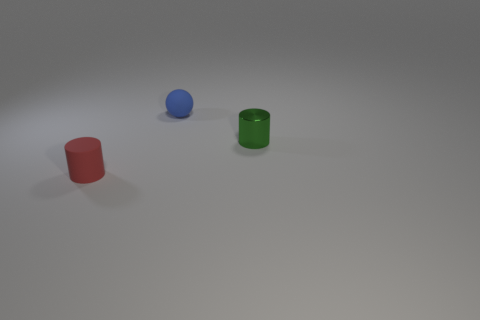How would you describe the overall mood or atmosphere conveyed by this image? The image conveys a simple, tranquil atmosphere, largely due to the minimalistic arrangement and the soft, diffused lighting. 